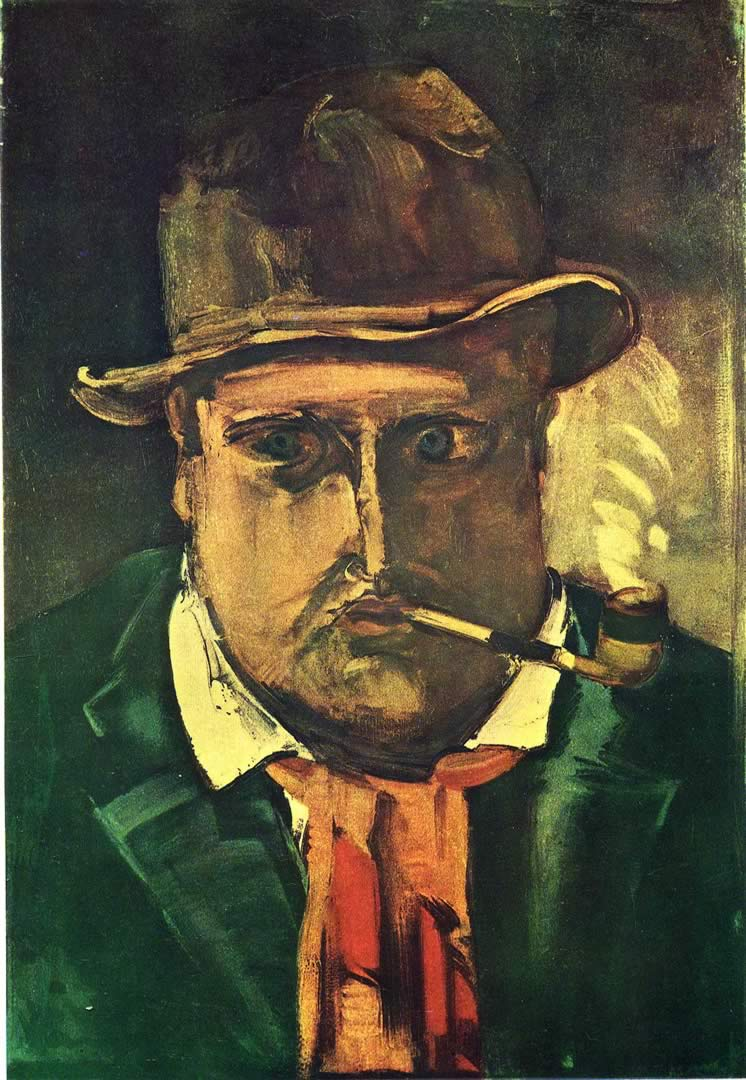Can you describe the main features of this image for me? The image depicts a man with a pronounced, emotional expression, characterized by dark, heavy brushstrokes that evoke a sense of turbulence and intensity. This man, donning a hat and smoking a pipe, is painted in an expressionist style, where reality is distorted to convey subjective emotions, rather than objective reality. The color palette is rich and moody, with dark greens and browns that suggest a somber mood, interspersed with highlights of red and yellow that draw attention to the man’s face and attire. This painting is likely an early 20th-century work, reflecting the era's artistic exploration of psychological depth and personal narrative. The expressionist movement often depicted individuals in moments of crisis or emotional intensity, which seems reflected in the man's imposing and introspective gaze, suggesting a deeper story behind his exterior. 